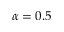Convert formula to latex. <formula><loc_0><loc_0><loc_500><loc_500>\alpha = 0 . 5</formula> 